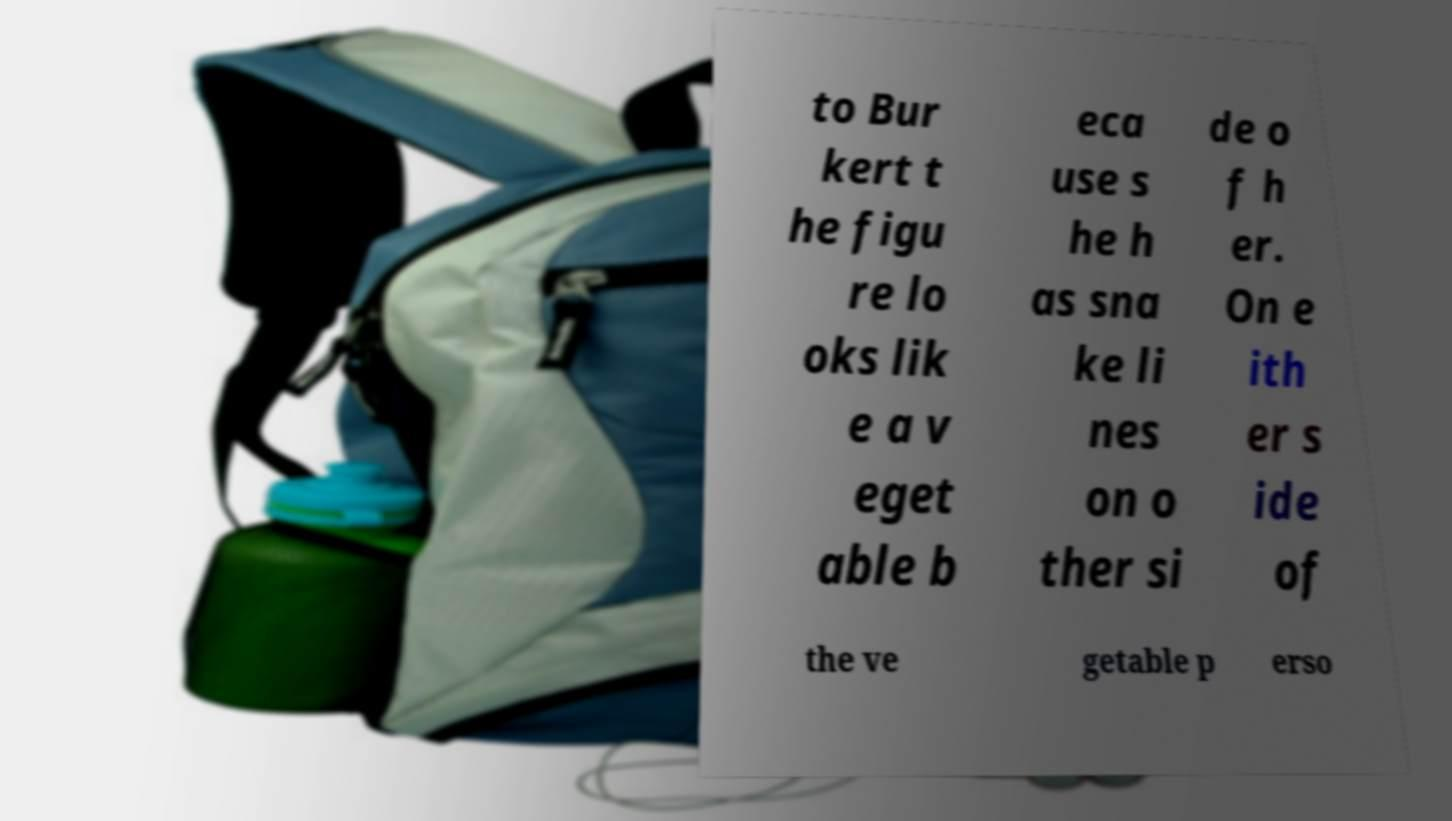For documentation purposes, I need the text within this image transcribed. Could you provide that? to Bur kert t he figu re lo oks lik e a v eget able b eca use s he h as sna ke li nes on o ther si de o f h er. On e ith er s ide of the ve getable p erso 